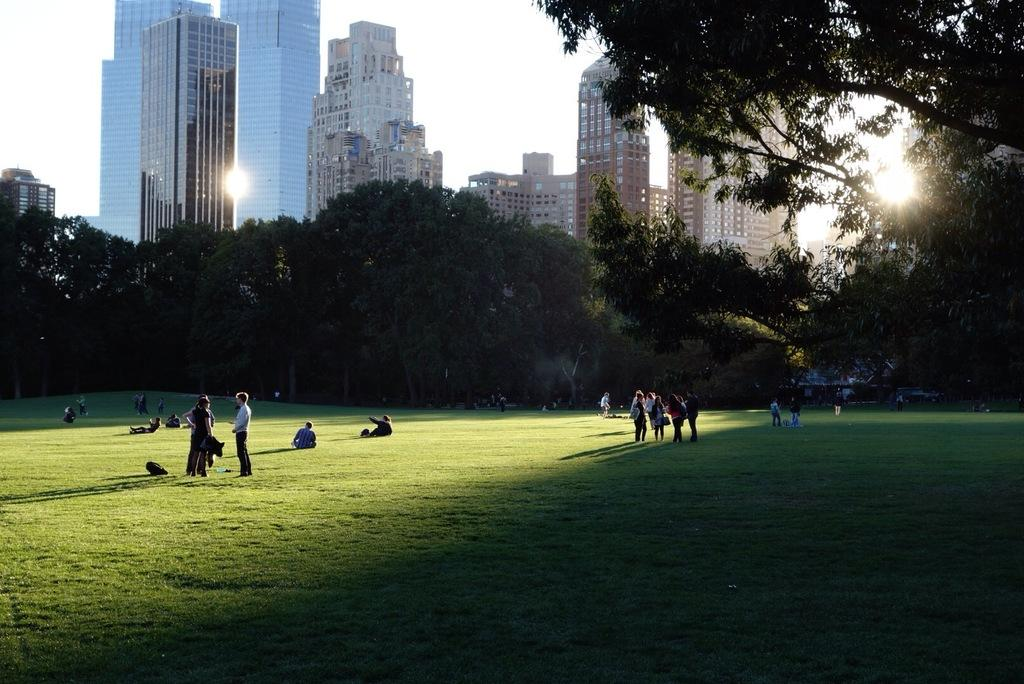How many people are in the image? There are people in the image, but the exact number is not specified. What are some of the people doing in the image? Some people are standing, and some are sitting on the grassland in the image. What can be seen in the background of the image? There are trees and skyscrapers in the background of the image. What type of deer can be seen interacting with the people in the image? There is no deer present in the image; it only features people, grassland, trees, and skyscrapers. What caused the people to gather in the image? The facts provided do not give any information about the cause or reason for the people gathering in the image. 